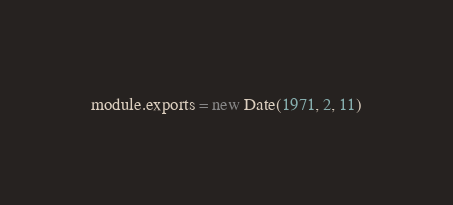Convert code to text. <code><loc_0><loc_0><loc_500><loc_500><_JavaScript_>module.exports = new Date(1971, 2, 11)
</code> 